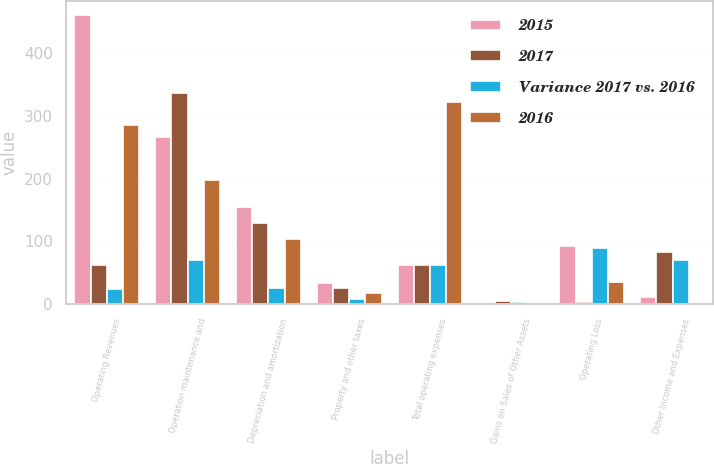<chart> <loc_0><loc_0><loc_500><loc_500><stacked_bar_chart><ecel><fcel>Operating Revenues<fcel>Operation maintenance and<fcel>Depreciation and amortization<fcel>Property and other taxes<fcel>Total operating expenses<fcel>Gains on Sales of Other Assets<fcel>Operating Loss<fcel>Other Income and Expenses<nl><fcel>2015<fcel>460<fcel>267<fcel>155<fcel>33<fcel>62<fcel>1<fcel>93<fcel>12<nl><fcel>2017<fcel>62<fcel>337<fcel>130<fcel>25<fcel>62<fcel>5<fcel>3<fcel>83<nl><fcel>Variance 2017 vs. 2016<fcel>24<fcel>70<fcel>25<fcel>8<fcel>62<fcel>4<fcel>90<fcel>71<nl><fcel>2016<fcel>286<fcel>197<fcel>104<fcel>18<fcel>322<fcel>1<fcel>35<fcel>2<nl></chart> 